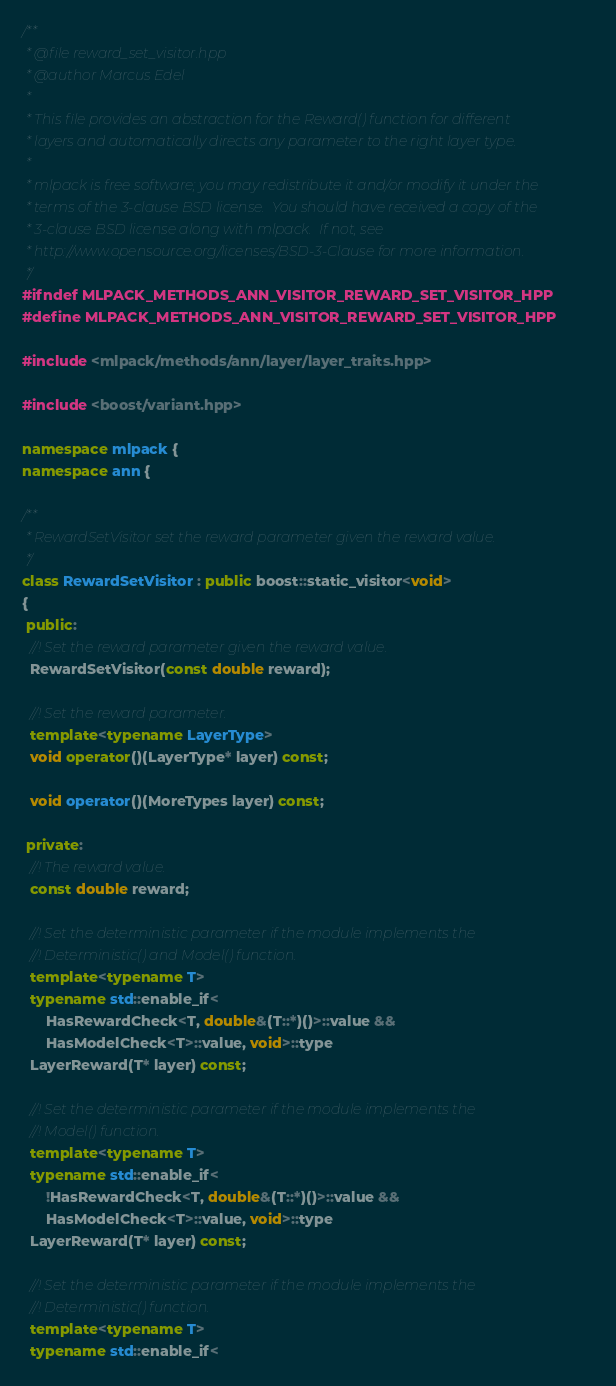<code> <loc_0><loc_0><loc_500><loc_500><_C++_>/**
 * @file reward_set_visitor.hpp
 * @author Marcus Edel
 *
 * This file provides an abstraction for the Reward() function for different
 * layers and automatically directs any parameter to the right layer type.
 *
 * mlpack is free software; you may redistribute it and/or modify it under the
 * terms of the 3-clause BSD license.  You should have received a copy of the
 * 3-clause BSD license along with mlpack.  If not, see
 * http://www.opensource.org/licenses/BSD-3-Clause for more information.
 */
#ifndef MLPACK_METHODS_ANN_VISITOR_REWARD_SET_VISITOR_HPP
#define MLPACK_METHODS_ANN_VISITOR_REWARD_SET_VISITOR_HPP

#include <mlpack/methods/ann/layer/layer_traits.hpp>

#include <boost/variant.hpp>

namespace mlpack {
namespace ann {

/**
 * RewardSetVisitor set the reward parameter given the reward value.
 */
class RewardSetVisitor : public boost::static_visitor<void>
{
 public:
  //! Set the reward parameter given the reward value.
  RewardSetVisitor(const double reward);

  //! Set the reward parameter.
  template<typename LayerType>
  void operator()(LayerType* layer) const;

  void operator()(MoreTypes layer) const;

 private:
  //! The reward value.
  const double reward;

  //! Set the deterministic parameter if the module implements the
  //! Deterministic() and Model() function.
  template<typename T>
  typename std::enable_if<
      HasRewardCheck<T, double&(T::*)()>::value &&
      HasModelCheck<T>::value, void>::type
  LayerReward(T* layer) const;

  //! Set the deterministic parameter if the module implements the
  //! Model() function.
  template<typename T>
  typename std::enable_if<
      !HasRewardCheck<T, double&(T::*)()>::value &&
      HasModelCheck<T>::value, void>::type
  LayerReward(T* layer) const;

  //! Set the deterministic parameter if the module implements the
  //! Deterministic() function.
  template<typename T>
  typename std::enable_if<</code> 